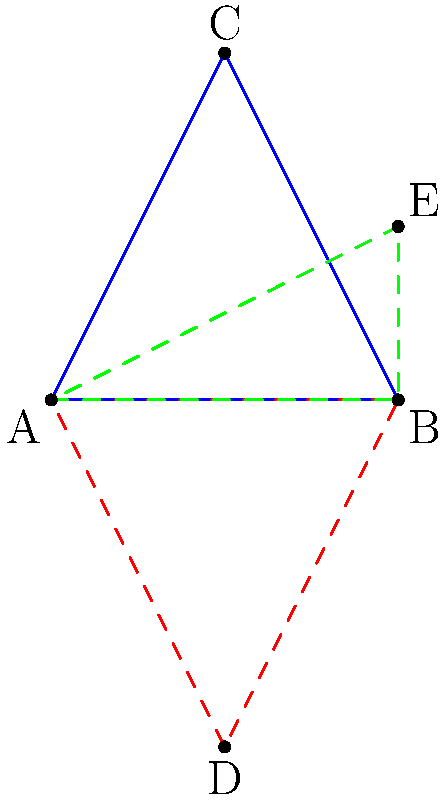Given triangle ABC, perform the following transformations in order:
1. Reflect triangle ABC over line AB to get triangle ABD.
2. Rotate triangle ABD 90° counterclockwise around point A to get triangle ABE.

What is the area of triangle ABE in terms of the area of the original triangle ABC? Let's approach this step-by-step:

1) First, let's consider the reflection:
   - Reflection preserves the shape and size of the original figure.
   - So, triangle ABD has the same area as triangle ABC.

2) Now, let's look at the rotation:
   - Rotation also preserves the shape and size of the figure.
   - So, triangle ABE has the same area as triangle ABD.

3) Combining these observations:
   - Area of triangle ABE = Area of triangle ABD = Area of triangle ABC

4) Therefore, the area of triangle ABE is equal to the area of the original triangle ABC.

This problem demonstrates an important principle in transformational geometry: isometries (such as reflections and rotations) preserve the area of shapes. This concept is crucial in many computer graphics and computational geometry algorithms, which are relevant to a computer science major interested in these fields.
Answer: The area of triangle ABE is equal to the area of triangle ABC. 